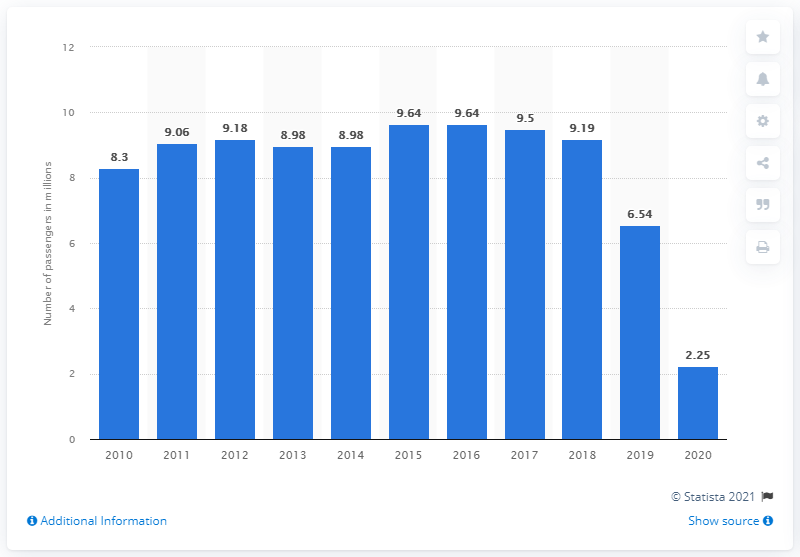Indicate a few pertinent items in this graphic. In 2020, the number of passengers traveling through Milan Linate Airport dropped to 2.22 million. 